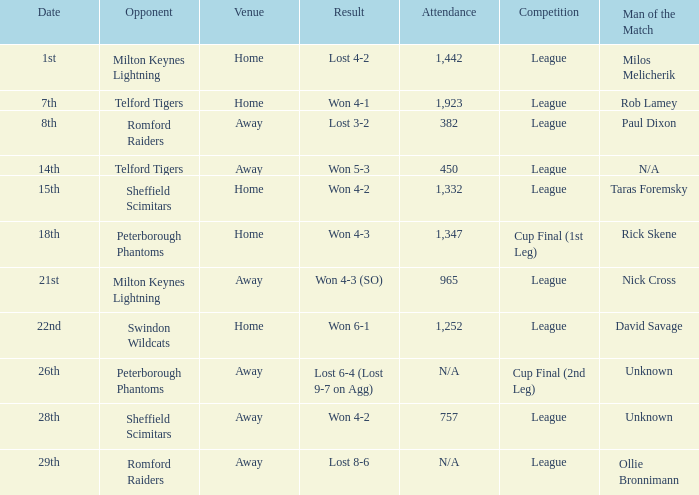What was the effect on the 26th? Lost 6-4 (Lost 9-7 on Agg). Parse the table in full. {'header': ['Date', 'Opponent', 'Venue', 'Result', 'Attendance', 'Competition', 'Man of the Match'], 'rows': [['1st', 'Milton Keynes Lightning', 'Home', 'Lost 4-2', '1,442', 'League', 'Milos Melicherik'], ['7th', 'Telford Tigers', 'Home', 'Won 4-1', '1,923', 'League', 'Rob Lamey'], ['8th', 'Romford Raiders', 'Away', 'Lost 3-2', '382', 'League', 'Paul Dixon'], ['14th', 'Telford Tigers', 'Away', 'Won 5-3', '450', 'League', 'N/A'], ['15th', 'Sheffield Scimitars', 'Home', 'Won 4-2', '1,332', 'League', 'Taras Foremsky'], ['18th', 'Peterborough Phantoms', 'Home', 'Won 4-3', '1,347', 'Cup Final (1st Leg)', 'Rick Skene'], ['21st', 'Milton Keynes Lightning', 'Away', 'Won 4-3 (SO)', '965', 'League', 'Nick Cross'], ['22nd', 'Swindon Wildcats', 'Home', 'Won 6-1', '1,252', 'League', 'David Savage'], ['26th', 'Peterborough Phantoms', 'Away', 'Lost 6-4 (Lost 9-7 on Agg)', 'N/A', 'Cup Final (2nd Leg)', 'Unknown'], ['28th', 'Sheffield Scimitars', 'Away', 'Won 4-2', '757', 'League', 'Unknown'], ['29th', 'Romford Raiders', 'Away', 'Lost 8-6', 'N/A', 'League', 'Ollie Bronnimann']]} 